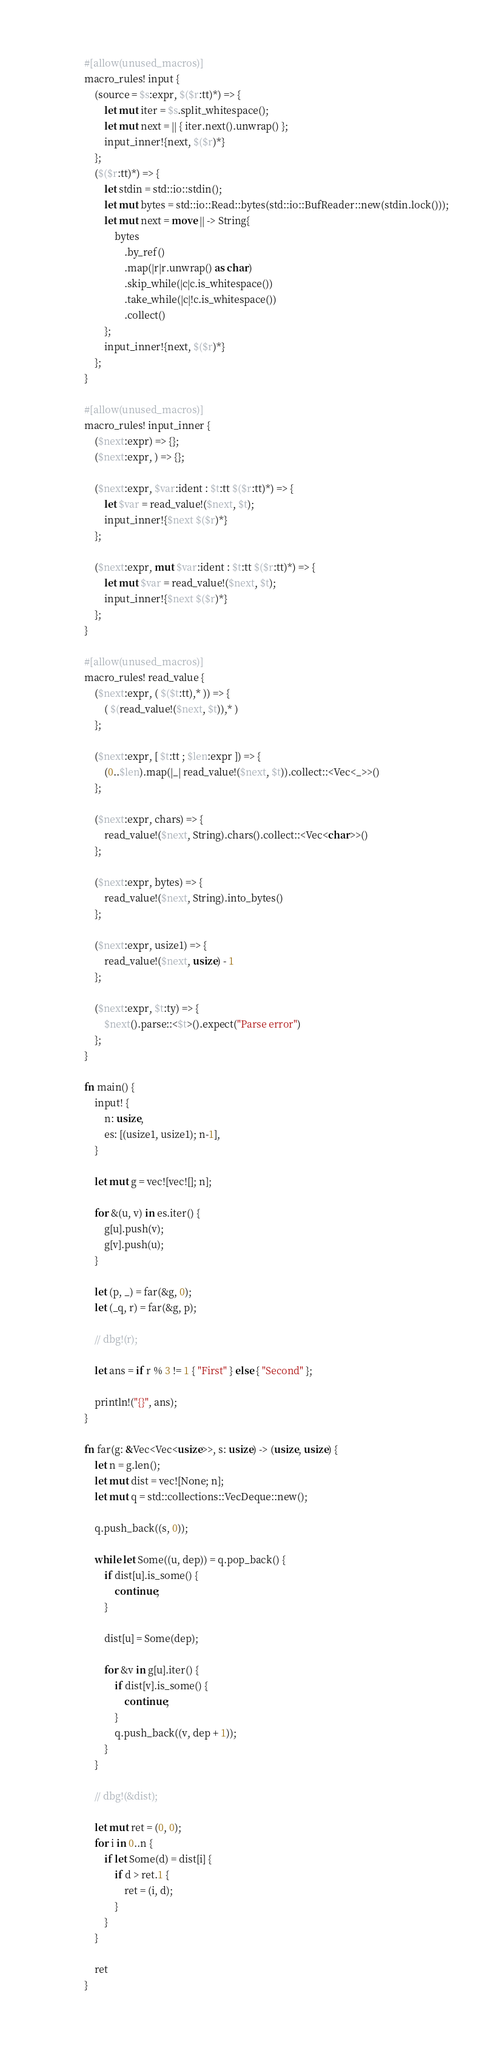Convert code to text. <code><loc_0><loc_0><loc_500><loc_500><_Rust_>#[allow(unused_macros)]
macro_rules! input {
    (source = $s:expr, $($r:tt)*) => {
        let mut iter = $s.split_whitespace();
        let mut next = || { iter.next().unwrap() };
        input_inner!{next, $($r)*}
    };
    ($($r:tt)*) => {
        let stdin = std::io::stdin();
        let mut bytes = std::io::Read::bytes(std::io::BufReader::new(stdin.lock()));
        let mut next = move || -> String{
            bytes
                .by_ref()
                .map(|r|r.unwrap() as char)
                .skip_while(|c|c.is_whitespace())
                .take_while(|c|!c.is_whitespace())
                .collect()
        };
        input_inner!{next, $($r)*}
    };
}

#[allow(unused_macros)]
macro_rules! input_inner {
    ($next:expr) => {};
    ($next:expr, ) => {};

    ($next:expr, $var:ident : $t:tt $($r:tt)*) => {
        let $var = read_value!($next, $t);
        input_inner!{$next $($r)*}
    };

    ($next:expr, mut $var:ident : $t:tt $($r:tt)*) => {
        let mut $var = read_value!($next, $t);
        input_inner!{$next $($r)*}
    };
}

#[allow(unused_macros)]
macro_rules! read_value {
    ($next:expr, ( $($t:tt),* )) => {
        ( $(read_value!($next, $t)),* )
    };

    ($next:expr, [ $t:tt ; $len:expr ]) => {
        (0..$len).map(|_| read_value!($next, $t)).collect::<Vec<_>>()
    };

    ($next:expr, chars) => {
        read_value!($next, String).chars().collect::<Vec<char>>()
    };

    ($next:expr, bytes) => {
        read_value!($next, String).into_bytes()
    };

    ($next:expr, usize1) => {
        read_value!($next, usize) - 1
    };

    ($next:expr, $t:ty) => {
        $next().parse::<$t>().expect("Parse error")
    };
}

fn main() {
    input! {
        n: usize,
        es: [(usize1, usize1); n-1],
    }

    let mut g = vec![vec![]; n];

    for &(u, v) in es.iter() {
        g[u].push(v);
        g[v].push(u);
    }

    let (p, _) = far(&g, 0);
    let (_q, r) = far(&g, p);

    // dbg!(r);

    let ans = if r % 3 != 1 { "First" } else { "Second" };

    println!("{}", ans);
}

fn far(g: &Vec<Vec<usize>>, s: usize) -> (usize, usize) {
    let n = g.len();
    let mut dist = vec![None; n];
    let mut q = std::collections::VecDeque::new();

    q.push_back((s, 0));

    while let Some((u, dep)) = q.pop_back() {
        if dist[u].is_some() {
            continue;
        }

        dist[u] = Some(dep);

        for &v in g[u].iter() {
            if dist[v].is_some() {
                continue;
            }
            q.push_back((v, dep + 1));
        }
    }

    // dbg!(&dist);

    let mut ret = (0, 0);
    for i in 0..n {
        if let Some(d) = dist[i] {
            if d > ret.1 {
                ret = (i, d);
            }
        }
    }

    ret
}
</code> 